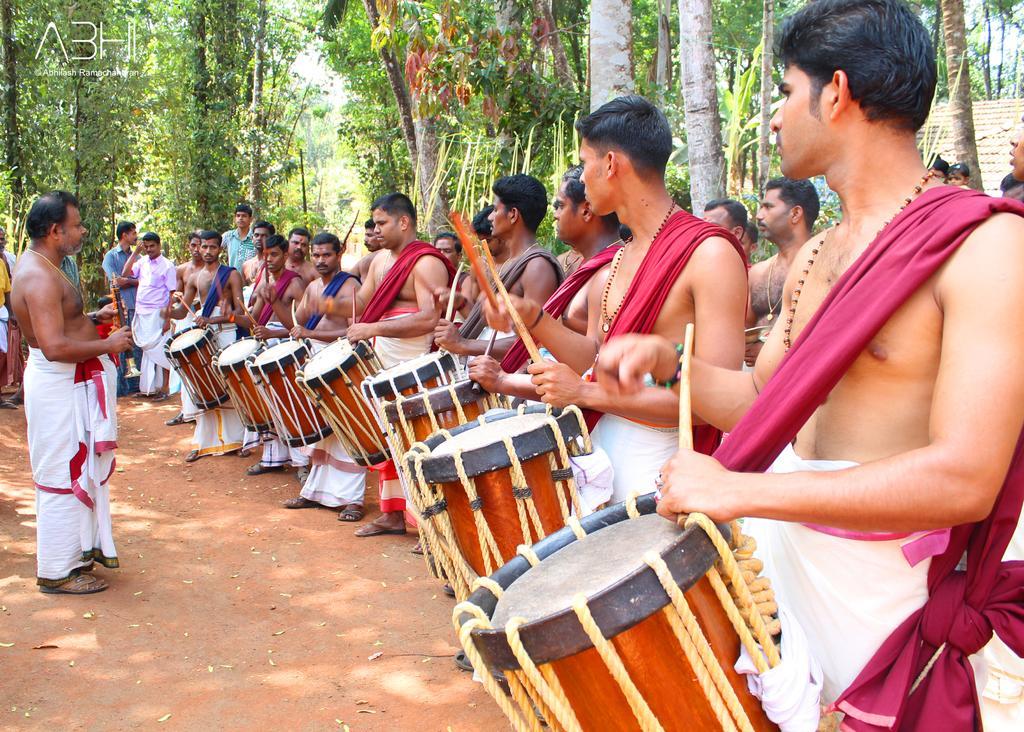In one or two sentences, can you explain what this image depicts? There are men standing and beating the drums, in the left side a man is standing, he wore a white color cloth. 